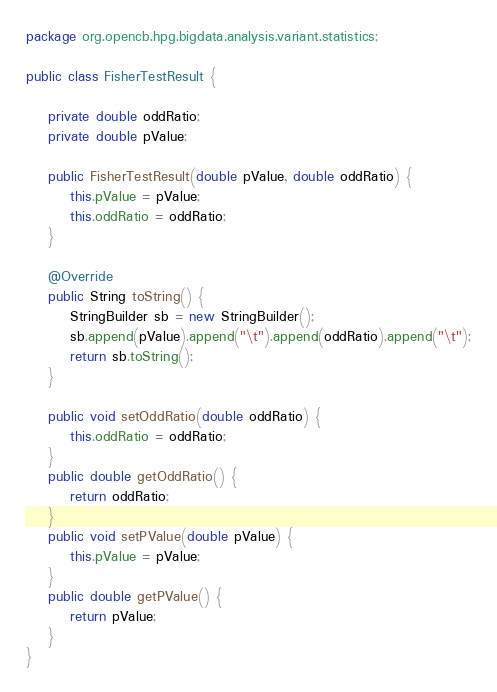<code> <loc_0><loc_0><loc_500><loc_500><_Java_>package org.opencb.hpg.bigdata.analysis.variant.statistics;

public class FisherTestResult {

    private double oddRatio;
    private double pValue;

    public FisherTestResult(double pValue, double oddRatio) {
        this.pValue = pValue;
        this.oddRatio = oddRatio;
    }

    @Override
    public String toString() {
        StringBuilder sb = new StringBuilder();
        sb.append(pValue).append("\t").append(oddRatio).append("\t");
        return sb.toString();
    }

    public void setOddRatio(double oddRatio) {
        this.oddRatio = oddRatio;
    }
    public double getOddRatio() {
        return oddRatio;
    }
    public void setPValue(double pValue) {
        this.pValue = pValue;
    }
    public double getPValue() {
        return pValue;
    }
}
</code> 